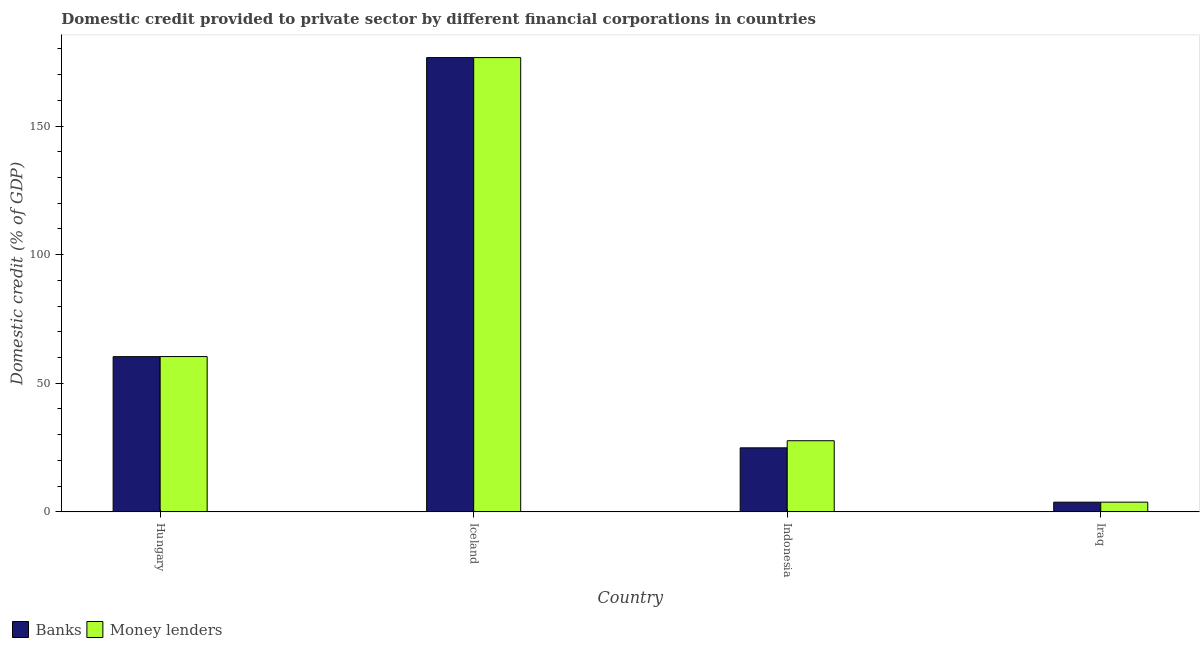How many groups of bars are there?
Offer a terse response. 4. Are the number of bars per tick equal to the number of legend labels?
Keep it short and to the point. Yes. How many bars are there on the 2nd tick from the right?
Give a very brief answer. 2. What is the label of the 4th group of bars from the left?
Keep it short and to the point. Iraq. What is the domestic credit provided by banks in Iceland?
Your answer should be very brief. 176.6. Across all countries, what is the maximum domestic credit provided by banks?
Give a very brief answer. 176.6. Across all countries, what is the minimum domestic credit provided by money lenders?
Ensure brevity in your answer.  3.78. In which country was the domestic credit provided by banks maximum?
Offer a very short reply. Iceland. In which country was the domestic credit provided by banks minimum?
Offer a terse response. Iraq. What is the total domestic credit provided by money lenders in the graph?
Your answer should be very brief. 268.42. What is the difference between the domestic credit provided by money lenders in Indonesia and that in Iraq?
Offer a very short reply. 23.88. What is the difference between the domestic credit provided by money lenders in Indonesia and the domestic credit provided by banks in Hungary?
Offer a terse response. -32.68. What is the average domestic credit provided by banks per country?
Make the answer very short. 66.4. What is the difference between the domestic credit provided by banks and domestic credit provided by money lenders in Iceland?
Make the answer very short. 0. In how many countries, is the domestic credit provided by banks greater than 110 %?
Give a very brief answer. 1. What is the ratio of the domestic credit provided by money lenders in Hungary to that in Iraq?
Provide a succinct answer. 15.98. Is the difference between the domestic credit provided by money lenders in Iceland and Iraq greater than the difference between the domestic credit provided by banks in Iceland and Iraq?
Offer a very short reply. No. What is the difference between the highest and the second highest domestic credit provided by money lenders?
Your response must be concise. 116.22. What is the difference between the highest and the lowest domestic credit provided by banks?
Provide a succinct answer. 172.82. In how many countries, is the domestic credit provided by money lenders greater than the average domestic credit provided by money lenders taken over all countries?
Make the answer very short. 1. What does the 1st bar from the left in Iceland represents?
Provide a short and direct response. Banks. What does the 2nd bar from the right in Indonesia represents?
Give a very brief answer. Banks. How many bars are there?
Make the answer very short. 8. Are all the bars in the graph horizontal?
Provide a short and direct response. No. What is the difference between two consecutive major ticks on the Y-axis?
Make the answer very short. 50. Are the values on the major ticks of Y-axis written in scientific E-notation?
Make the answer very short. No. Does the graph contain any zero values?
Provide a succinct answer. No. Does the graph contain grids?
Provide a succinct answer. No. Where does the legend appear in the graph?
Your answer should be very brief. Bottom left. What is the title of the graph?
Provide a short and direct response. Domestic credit provided to private sector by different financial corporations in countries. Does "Overweight" appear as one of the legend labels in the graph?
Offer a very short reply. No. What is the label or title of the Y-axis?
Offer a terse response. Domestic credit (% of GDP). What is the Domestic credit (% of GDP) in Banks in Hungary?
Offer a terse response. 60.34. What is the Domestic credit (% of GDP) of Money lenders in Hungary?
Ensure brevity in your answer.  60.38. What is the Domestic credit (% of GDP) of Banks in Iceland?
Provide a succinct answer. 176.6. What is the Domestic credit (% of GDP) of Money lenders in Iceland?
Your response must be concise. 176.6. What is the Domestic credit (% of GDP) in Banks in Indonesia?
Make the answer very short. 24.89. What is the Domestic credit (% of GDP) in Money lenders in Indonesia?
Your response must be concise. 27.66. What is the Domestic credit (% of GDP) of Banks in Iraq?
Your response must be concise. 3.78. What is the Domestic credit (% of GDP) of Money lenders in Iraq?
Make the answer very short. 3.78. Across all countries, what is the maximum Domestic credit (% of GDP) of Banks?
Your response must be concise. 176.6. Across all countries, what is the maximum Domestic credit (% of GDP) of Money lenders?
Make the answer very short. 176.6. Across all countries, what is the minimum Domestic credit (% of GDP) of Banks?
Your answer should be very brief. 3.78. Across all countries, what is the minimum Domestic credit (% of GDP) of Money lenders?
Your answer should be very brief. 3.78. What is the total Domestic credit (% of GDP) of Banks in the graph?
Give a very brief answer. 265.62. What is the total Domestic credit (% of GDP) in Money lenders in the graph?
Keep it short and to the point. 268.42. What is the difference between the Domestic credit (% of GDP) of Banks in Hungary and that in Iceland?
Your answer should be very brief. -116.26. What is the difference between the Domestic credit (% of GDP) in Money lenders in Hungary and that in Iceland?
Your response must be concise. -116.22. What is the difference between the Domestic credit (% of GDP) in Banks in Hungary and that in Indonesia?
Your answer should be very brief. 35.45. What is the difference between the Domestic credit (% of GDP) in Money lenders in Hungary and that in Indonesia?
Your answer should be very brief. 32.72. What is the difference between the Domestic credit (% of GDP) of Banks in Hungary and that in Iraq?
Offer a terse response. 56.57. What is the difference between the Domestic credit (% of GDP) of Money lenders in Hungary and that in Iraq?
Offer a very short reply. 56.6. What is the difference between the Domestic credit (% of GDP) in Banks in Iceland and that in Indonesia?
Your answer should be very brief. 151.71. What is the difference between the Domestic credit (% of GDP) in Money lenders in Iceland and that in Indonesia?
Ensure brevity in your answer.  148.94. What is the difference between the Domestic credit (% of GDP) of Banks in Iceland and that in Iraq?
Your answer should be compact. 172.82. What is the difference between the Domestic credit (% of GDP) of Money lenders in Iceland and that in Iraq?
Offer a terse response. 172.82. What is the difference between the Domestic credit (% of GDP) of Banks in Indonesia and that in Iraq?
Ensure brevity in your answer.  21.12. What is the difference between the Domestic credit (% of GDP) in Money lenders in Indonesia and that in Iraq?
Offer a terse response. 23.88. What is the difference between the Domestic credit (% of GDP) in Banks in Hungary and the Domestic credit (% of GDP) in Money lenders in Iceland?
Provide a succinct answer. -116.26. What is the difference between the Domestic credit (% of GDP) in Banks in Hungary and the Domestic credit (% of GDP) in Money lenders in Indonesia?
Ensure brevity in your answer.  32.69. What is the difference between the Domestic credit (% of GDP) in Banks in Hungary and the Domestic credit (% of GDP) in Money lenders in Iraq?
Your answer should be very brief. 56.56. What is the difference between the Domestic credit (% of GDP) of Banks in Iceland and the Domestic credit (% of GDP) of Money lenders in Indonesia?
Offer a terse response. 148.94. What is the difference between the Domestic credit (% of GDP) of Banks in Iceland and the Domestic credit (% of GDP) of Money lenders in Iraq?
Your answer should be very brief. 172.82. What is the difference between the Domestic credit (% of GDP) in Banks in Indonesia and the Domestic credit (% of GDP) in Money lenders in Iraq?
Your response must be concise. 21.12. What is the average Domestic credit (% of GDP) of Banks per country?
Make the answer very short. 66.4. What is the average Domestic credit (% of GDP) of Money lenders per country?
Your answer should be compact. 67.1. What is the difference between the Domestic credit (% of GDP) in Banks and Domestic credit (% of GDP) in Money lenders in Hungary?
Make the answer very short. -0.04. What is the difference between the Domestic credit (% of GDP) of Banks and Domestic credit (% of GDP) of Money lenders in Iceland?
Give a very brief answer. 0. What is the difference between the Domestic credit (% of GDP) of Banks and Domestic credit (% of GDP) of Money lenders in Indonesia?
Your answer should be compact. -2.76. What is the difference between the Domestic credit (% of GDP) of Banks and Domestic credit (% of GDP) of Money lenders in Iraq?
Make the answer very short. -0. What is the ratio of the Domestic credit (% of GDP) of Banks in Hungary to that in Iceland?
Your answer should be very brief. 0.34. What is the ratio of the Domestic credit (% of GDP) of Money lenders in Hungary to that in Iceland?
Make the answer very short. 0.34. What is the ratio of the Domestic credit (% of GDP) of Banks in Hungary to that in Indonesia?
Offer a terse response. 2.42. What is the ratio of the Domestic credit (% of GDP) of Money lenders in Hungary to that in Indonesia?
Offer a terse response. 2.18. What is the ratio of the Domestic credit (% of GDP) in Banks in Hungary to that in Iraq?
Keep it short and to the point. 15.97. What is the ratio of the Domestic credit (% of GDP) of Money lenders in Hungary to that in Iraq?
Offer a terse response. 15.98. What is the ratio of the Domestic credit (% of GDP) of Banks in Iceland to that in Indonesia?
Keep it short and to the point. 7.09. What is the ratio of the Domestic credit (% of GDP) of Money lenders in Iceland to that in Indonesia?
Make the answer very short. 6.38. What is the ratio of the Domestic credit (% of GDP) of Banks in Iceland to that in Iraq?
Give a very brief answer. 46.75. What is the ratio of the Domestic credit (% of GDP) in Money lenders in Iceland to that in Iraq?
Your answer should be compact. 46.74. What is the ratio of the Domestic credit (% of GDP) of Banks in Indonesia to that in Iraq?
Ensure brevity in your answer.  6.59. What is the ratio of the Domestic credit (% of GDP) in Money lenders in Indonesia to that in Iraq?
Your answer should be compact. 7.32. What is the difference between the highest and the second highest Domestic credit (% of GDP) in Banks?
Make the answer very short. 116.26. What is the difference between the highest and the second highest Domestic credit (% of GDP) of Money lenders?
Your response must be concise. 116.22. What is the difference between the highest and the lowest Domestic credit (% of GDP) of Banks?
Give a very brief answer. 172.82. What is the difference between the highest and the lowest Domestic credit (% of GDP) of Money lenders?
Your response must be concise. 172.82. 